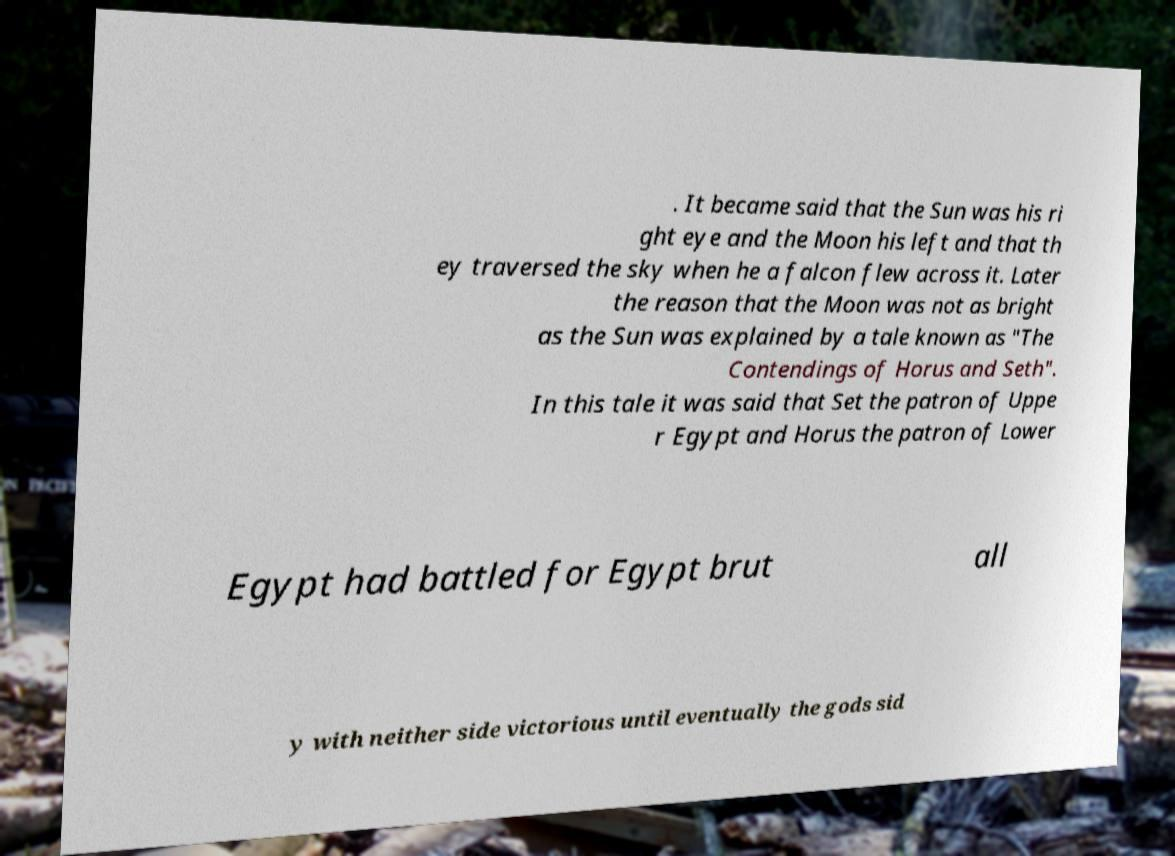Could you assist in decoding the text presented in this image and type it out clearly? . It became said that the Sun was his ri ght eye and the Moon his left and that th ey traversed the sky when he a falcon flew across it. Later the reason that the Moon was not as bright as the Sun was explained by a tale known as "The Contendings of Horus and Seth". In this tale it was said that Set the patron of Uppe r Egypt and Horus the patron of Lower Egypt had battled for Egypt brut all y with neither side victorious until eventually the gods sid 